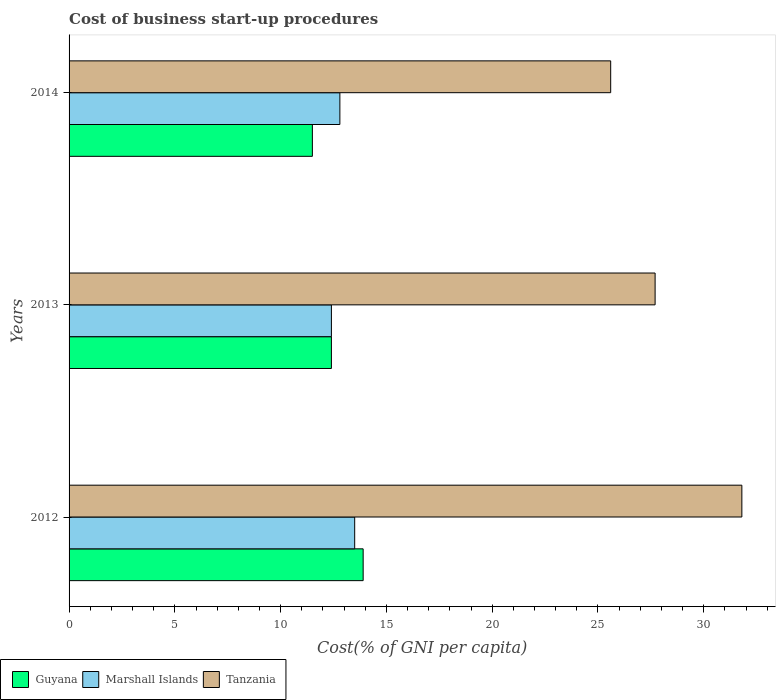How many different coloured bars are there?
Keep it short and to the point. 3. Are the number of bars on each tick of the Y-axis equal?
Offer a very short reply. Yes. What is the label of the 3rd group of bars from the top?
Your response must be concise. 2012. What is the cost of business start-up procedures in Guyana in 2012?
Your answer should be compact. 13.9. Across all years, what is the maximum cost of business start-up procedures in Guyana?
Your answer should be compact. 13.9. Across all years, what is the minimum cost of business start-up procedures in Tanzania?
Keep it short and to the point. 25.6. In which year was the cost of business start-up procedures in Guyana maximum?
Give a very brief answer. 2012. In which year was the cost of business start-up procedures in Marshall Islands minimum?
Your answer should be compact. 2013. What is the total cost of business start-up procedures in Guyana in the graph?
Offer a very short reply. 37.8. What is the difference between the cost of business start-up procedures in Tanzania in 2012 and that in 2013?
Your answer should be compact. 4.1. What is the average cost of business start-up procedures in Marshall Islands per year?
Your answer should be very brief. 12.9. In how many years, is the cost of business start-up procedures in Marshall Islands greater than 2 %?
Offer a terse response. 3. What is the ratio of the cost of business start-up procedures in Marshall Islands in 2012 to that in 2014?
Your response must be concise. 1.05. Is the cost of business start-up procedures in Tanzania in 2012 less than that in 2014?
Your response must be concise. No. Is the difference between the cost of business start-up procedures in Tanzania in 2012 and 2014 greater than the difference between the cost of business start-up procedures in Guyana in 2012 and 2014?
Offer a terse response. Yes. What is the difference between the highest and the second highest cost of business start-up procedures in Guyana?
Ensure brevity in your answer.  1.5. What is the difference between the highest and the lowest cost of business start-up procedures in Guyana?
Ensure brevity in your answer.  2.4. In how many years, is the cost of business start-up procedures in Guyana greater than the average cost of business start-up procedures in Guyana taken over all years?
Keep it short and to the point. 1. Is the sum of the cost of business start-up procedures in Tanzania in 2013 and 2014 greater than the maximum cost of business start-up procedures in Guyana across all years?
Provide a short and direct response. Yes. What does the 2nd bar from the top in 2013 represents?
Your answer should be very brief. Marshall Islands. What does the 1st bar from the bottom in 2012 represents?
Offer a terse response. Guyana. Are all the bars in the graph horizontal?
Your answer should be compact. Yes. How many years are there in the graph?
Ensure brevity in your answer.  3. What is the difference between two consecutive major ticks on the X-axis?
Provide a succinct answer. 5. Where does the legend appear in the graph?
Provide a short and direct response. Bottom left. How many legend labels are there?
Ensure brevity in your answer.  3. How are the legend labels stacked?
Ensure brevity in your answer.  Horizontal. What is the title of the graph?
Your response must be concise. Cost of business start-up procedures. Does "Thailand" appear as one of the legend labels in the graph?
Provide a succinct answer. No. What is the label or title of the X-axis?
Make the answer very short. Cost(% of GNI per capita). What is the label or title of the Y-axis?
Provide a short and direct response. Years. What is the Cost(% of GNI per capita) of Tanzania in 2012?
Make the answer very short. 31.8. What is the Cost(% of GNI per capita) of Guyana in 2013?
Provide a short and direct response. 12.4. What is the Cost(% of GNI per capita) of Marshall Islands in 2013?
Offer a very short reply. 12.4. What is the Cost(% of GNI per capita) of Tanzania in 2013?
Offer a terse response. 27.7. What is the Cost(% of GNI per capita) of Tanzania in 2014?
Provide a short and direct response. 25.6. Across all years, what is the maximum Cost(% of GNI per capita) in Marshall Islands?
Your answer should be very brief. 13.5. Across all years, what is the maximum Cost(% of GNI per capita) in Tanzania?
Give a very brief answer. 31.8. Across all years, what is the minimum Cost(% of GNI per capita) of Marshall Islands?
Your answer should be compact. 12.4. Across all years, what is the minimum Cost(% of GNI per capita) of Tanzania?
Provide a succinct answer. 25.6. What is the total Cost(% of GNI per capita) of Guyana in the graph?
Provide a succinct answer. 37.8. What is the total Cost(% of GNI per capita) of Marshall Islands in the graph?
Your answer should be very brief. 38.7. What is the total Cost(% of GNI per capita) of Tanzania in the graph?
Your answer should be very brief. 85.1. What is the difference between the Cost(% of GNI per capita) in Marshall Islands in 2012 and that in 2013?
Ensure brevity in your answer.  1.1. What is the difference between the Cost(% of GNI per capita) in Tanzania in 2012 and that in 2013?
Give a very brief answer. 4.1. What is the difference between the Cost(% of GNI per capita) of Guyana in 2012 and that in 2014?
Give a very brief answer. 2.4. What is the difference between the Cost(% of GNI per capita) of Guyana in 2012 and the Cost(% of GNI per capita) of Marshall Islands in 2014?
Ensure brevity in your answer.  1.1. What is the difference between the Cost(% of GNI per capita) in Marshall Islands in 2012 and the Cost(% of GNI per capita) in Tanzania in 2014?
Make the answer very short. -12.1. What is the difference between the Cost(% of GNI per capita) in Marshall Islands in 2013 and the Cost(% of GNI per capita) in Tanzania in 2014?
Ensure brevity in your answer.  -13.2. What is the average Cost(% of GNI per capita) in Marshall Islands per year?
Offer a very short reply. 12.9. What is the average Cost(% of GNI per capita) in Tanzania per year?
Your answer should be compact. 28.37. In the year 2012, what is the difference between the Cost(% of GNI per capita) in Guyana and Cost(% of GNI per capita) in Marshall Islands?
Your answer should be very brief. 0.4. In the year 2012, what is the difference between the Cost(% of GNI per capita) of Guyana and Cost(% of GNI per capita) of Tanzania?
Make the answer very short. -17.9. In the year 2012, what is the difference between the Cost(% of GNI per capita) of Marshall Islands and Cost(% of GNI per capita) of Tanzania?
Give a very brief answer. -18.3. In the year 2013, what is the difference between the Cost(% of GNI per capita) of Guyana and Cost(% of GNI per capita) of Tanzania?
Make the answer very short. -15.3. In the year 2013, what is the difference between the Cost(% of GNI per capita) of Marshall Islands and Cost(% of GNI per capita) of Tanzania?
Offer a very short reply. -15.3. In the year 2014, what is the difference between the Cost(% of GNI per capita) of Guyana and Cost(% of GNI per capita) of Marshall Islands?
Ensure brevity in your answer.  -1.3. In the year 2014, what is the difference between the Cost(% of GNI per capita) of Guyana and Cost(% of GNI per capita) of Tanzania?
Provide a succinct answer. -14.1. In the year 2014, what is the difference between the Cost(% of GNI per capita) of Marshall Islands and Cost(% of GNI per capita) of Tanzania?
Ensure brevity in your answer.  -12.8. What is the ratio of the Cost(% of GNI per capita) of Guyana in 2012 to that in 2013?
Offer a terse response. 1.12. What is the ratio of the Cost(% of GNI per capita) of Marshall Islands in 2012 to that in 2013?
Ensure brevity in your answer.  1.09. What is the ratio of the Cost(% of GNI per capita) in Tanzania in 2012 to that in 2013?
Your answer should be compact. 1.15. What is the ratio of the Cost(% of GNI per capita) in Guyana in 2012 to that in 2014?
Make the answer very short. 1.21. What is the ratio of the Cost(% of GNI per capita) in Marshall Islands in 2012 to that in 2014?
Give a very brief answer. 1.05. What is the ratio of the Cost(% of GNI per capita) in Tanzania in 2012 to that in 2014?
Provide a succinct answer. 1.24. What is the ratio of the Cost(% of GNI per capita) of Guyana in 2013 to that in 2014?
Your answer should be very brief. 1.08. What is the ratio of the Cost(% of GNI per capita) in Marshall Islands in 2013 to that in 2014?
Provide a succinct answer. 0.97. What is the ratio of the Cost(% of GNI per capita) in Tanzania in 2013 to that in 2014?
Provide a short and direct response. 1.08. What is the difference between the highest and the second highest Cost(% of GNI per capita) in Guyana?
Offer a terse response. 1.5. What is the difference between the highest and the second highest Cost(% of GNI per capita) in Marshall Islands?
Ensure brevity in your answer.  0.7. What is the difference between the highest and the second highest Cost(% of GNI per capita) in Tanzania?
Your answer should be compact. 4.1. 